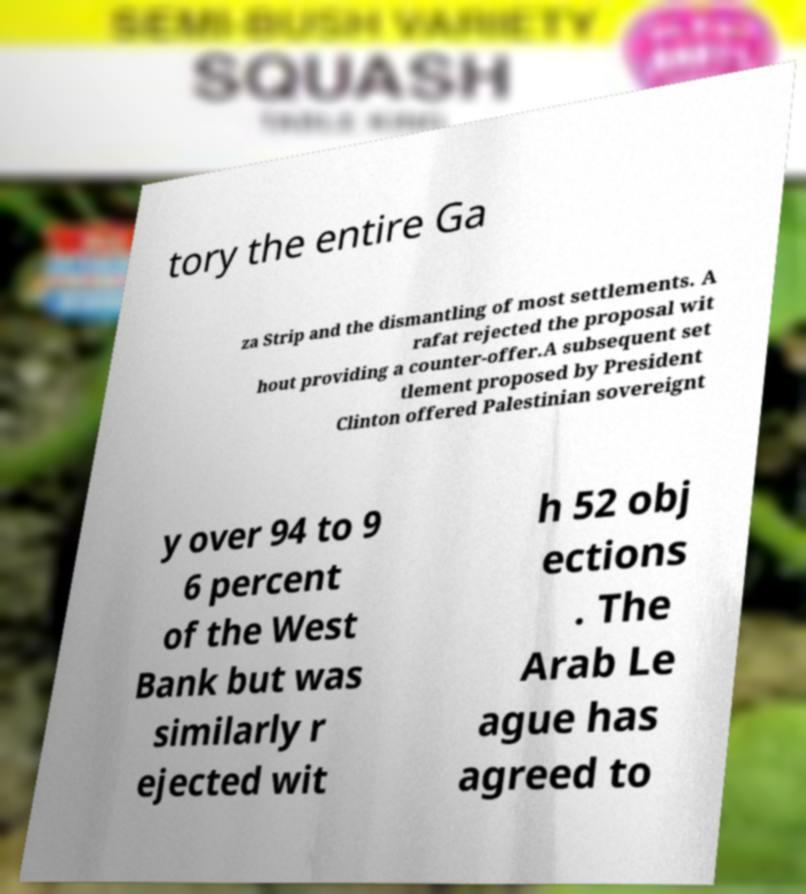I need the written content from this picture converted into text. Can you do that? tory the entire Ga za Strip and the dismantling of most settlements. A rafat rejected the proposal wit hout providing a counter-offer.A subsequent set tlement proposed by President Clinton offered Palestinian sovereignt y over 94 to 9 6 percent of the West Bank but was similarly r ejected wit h 52 obj ections . The Arab Le ague has agreed to 